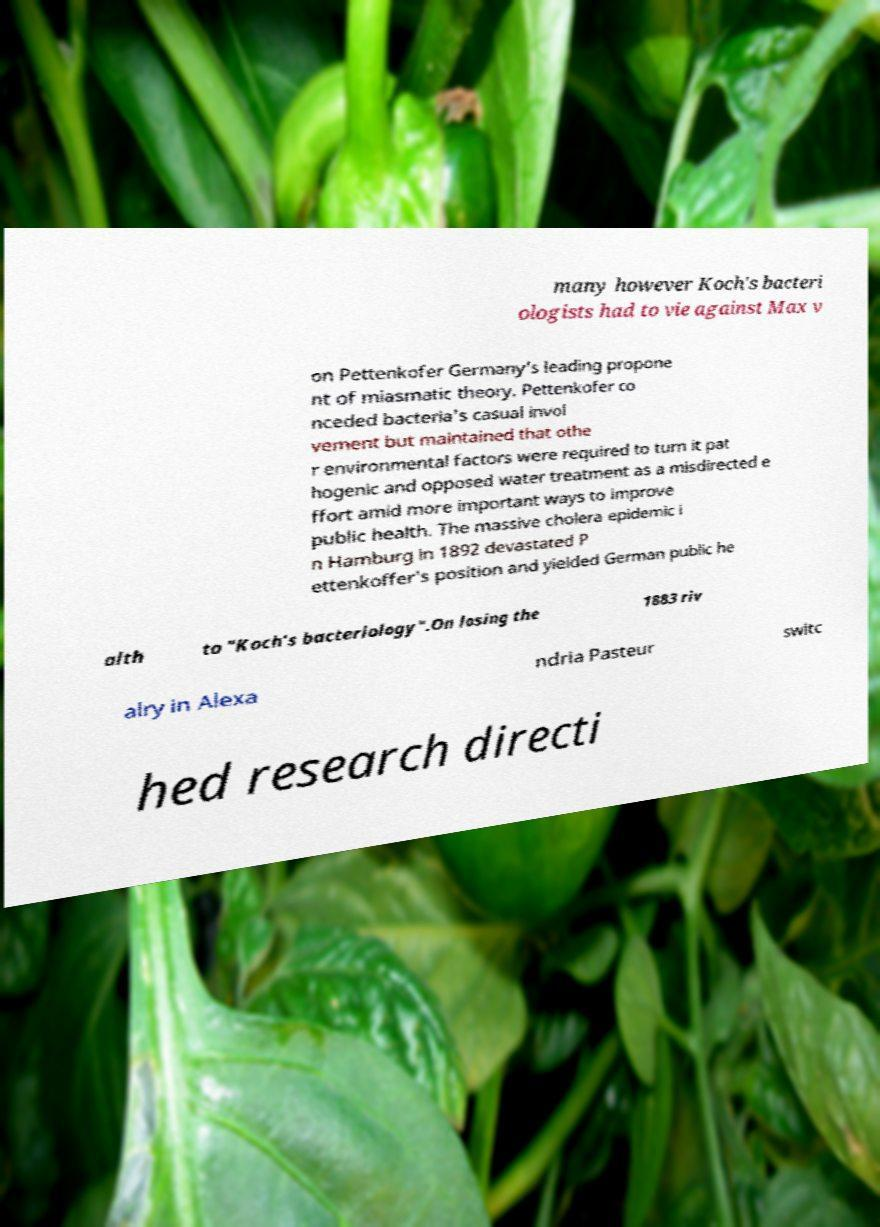Please identify and transcribe the text found in this image. many however Koch's bacteri ologists had to vie against Max v on Pettenkofer Germany's leading propone nt of miasmatic theory. Pettenkofer co nceded bacteria's casual invol vement but maintained that othe r environmental factors were required to turn it pat hogenic and opposed water treatment as a misdirected e ffort amid more important ways to improve public health. The massive cholera epidemic i n Hamburg in 1892 devastated P ettenkoffer's position and yielded German public he alth to "Koch's bacteriology".On losing the 1883 riv alry in Alexa ndria Pasteur switc hed research directi 